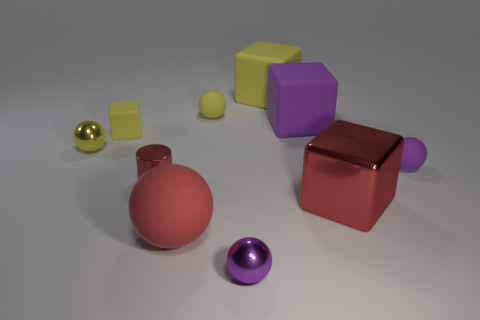Subtract all red rubber spheres. How many spheres are left? 4 Subtract all red balls. How many balls are left? 4 Subtract 1 blocks. How many blocks are left? 3 Subtract all green balls. Subtract all yellow cylinders. How many balls are left? 5 Subtract all cylinders. How many objects are left? 9 Subtract all tiny metal spheres. Subtract all tiny blocks. How many objects are left? 7 Add 1 big metallic things. How many big metallic things are left? 2 Add 2 tiny red shiny things. How many tiny red shiny things exist? 3 Subtract 0 green cylinders. How many objects are left? 10 